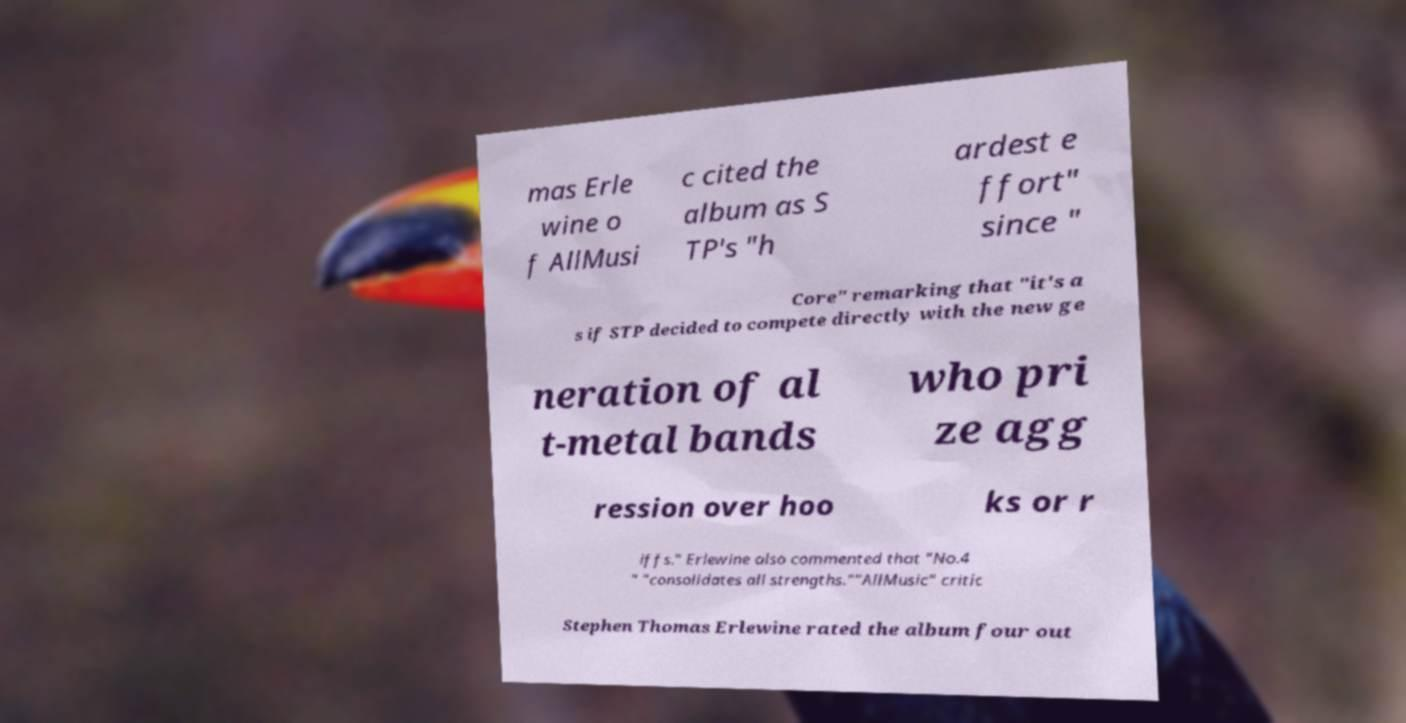Please identify and transcribe the text found in this image. mas Erle wine o f AllMusi c cited the album as S TP's "h ardest e ffort" since " Core" remarking that "it's a s if STP decided to compete directly with the new ge neration of al t-metal bands who pri ze agg ression over hoo ks or r iffs." Erlewine also commented that "No.4 " "consolidates all strengths.""AllMusic" critic Stephen Thomas Erlewine rated the album four out 